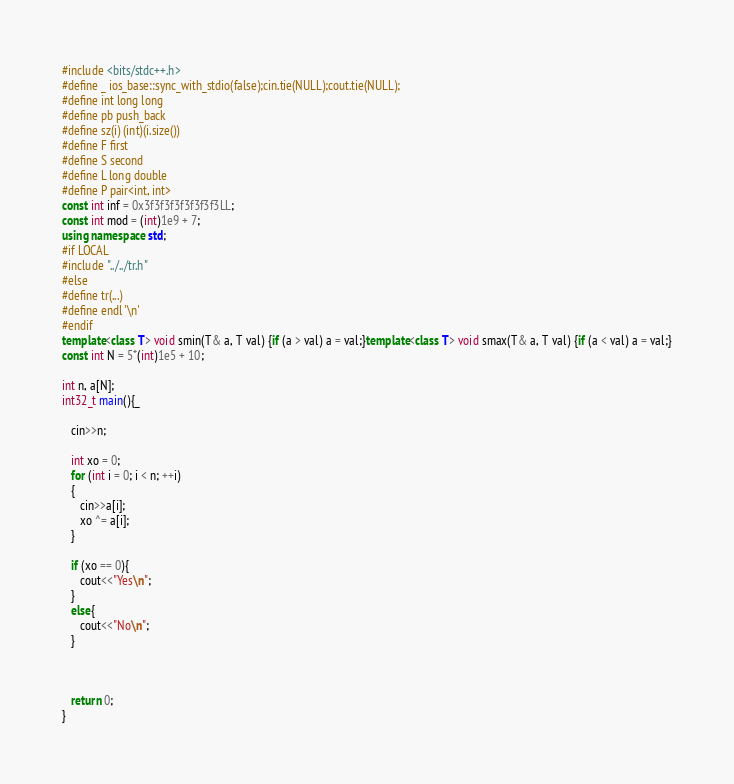Convert code to text. <code><loc_0><loc_0><loc_500><loc_500><_C++_>#include <bits/stdc++.h>
#define _ ios_base::sync_with_stdio(false);cin.tie(NULL);cout.tie(NULL);
#define int long long
#define pb push_back
#define sz(i) (int)(i.size())
#define F first
#define S second
#define L long double
#define P pair<int, int>
const int inf = 0x3f3f3f3f3f3f3f3LL;
const int mod = (int)1e9 + 7;
using namespace std;
#if LOCAL
#include "../../tr.h"
#else
#define tr(...)
#define endl '\n'
#endif
template<class T> void smin(T& a, T val) {if (a > val) a = val;}template<class T> void smax(T& a, T val) {if (a < val) a = val;}
const int N = 5*(int)1e5 + 10;

int n, a[N];
int32_t main(){_

   cin>>n;

   int xo = 0;
   for (int i = 0; i < n; ++i)
   {
      cin>>a[i];
      xo ^= a[i];
   }

   if (xo == 0){
      cout<<"Yes\n";
   }
   else{
      cout<<"No\n";
   }

   

   return 0;
}</code> 